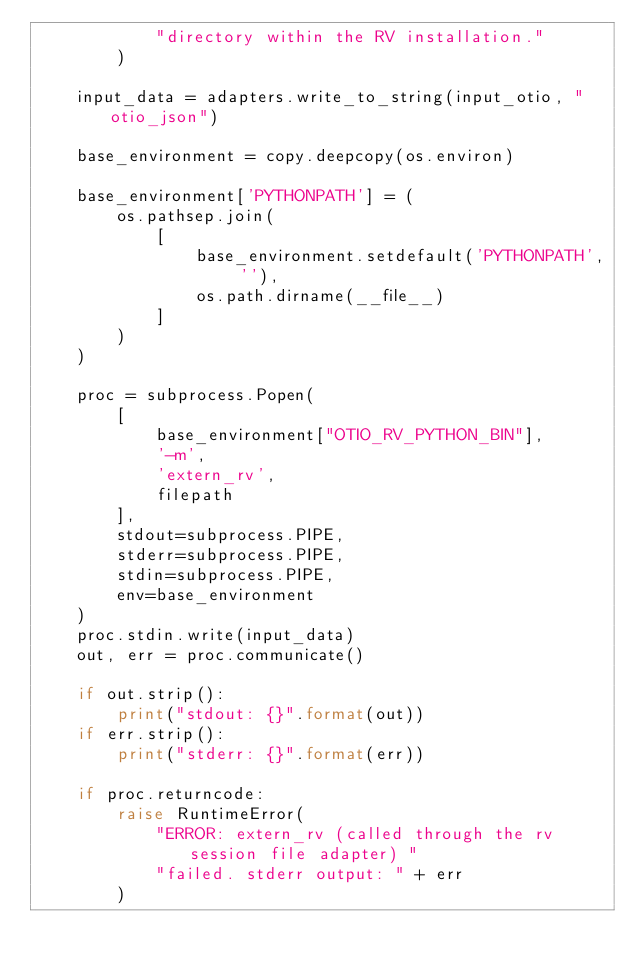<code> <loc_0><loc_0><loc_500><loc_500><_Python_>            "directory within the RV installation."
        )

    input_data = adapters.write_to_string(input_otio, "otio_json")

    base_environment = copy.deepcopy(os.environ)

    base_environment['PYTHONPATH'] = (
        os.pathsep.join(
            [
                base_environment.setdefault('PYTHONPATH', ''),
                os.path.dirname(__file__)
            ]
        )
    )

    proc = subprocess.Popen(
        [
            base_environment["OTIO_RV_PYTHON_BIN"],
            '-m',
            'extern_rv',
            filepath
        ],
        stdout=subprocess.PIPE,
        stderr=subprocess.PIPE,
        stdin=subprocess.PIPE,
        env=base_environment
    )
    proc.stdin.write(input_data)
    out, err = proc.communicate()

    if out.strip():
        print("stdout: {}".format(out))
    if err.strip():
        print("stderr: {}".format(err))

    if proc.returncode:
        raise RuntimeError(
            "ERROR: extern_rv (called through the rv session file adapter) "
            "failed. stderr output: " + err
        )
</code> 